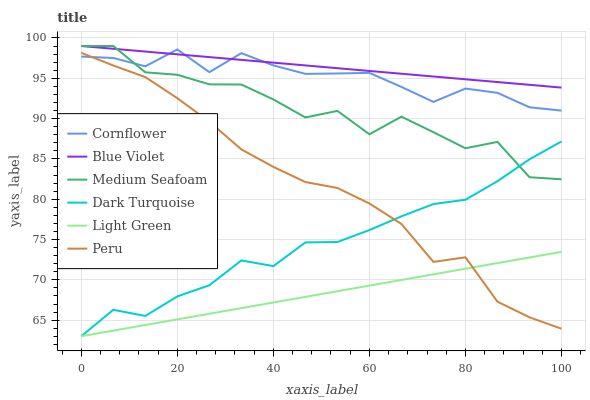Does Light Green have the minimum area under the curve?
Answer yes or no. Yes. Does Blue Violet have the maximum area under the curve?
Answer yes or no. Yes. Does Dark Turquoise have the minimum area under the curve?
Answer yes or no. No. Does Dark Turquoise have the maximum area under the curve?
Answer yes or no. No. Is Light Green the smoothest?
Answer yes or no. Yes. Is Medium Seafoam the roughest?
Answer yes or no. Yes. Is Dark Turquoise the smoothest?
Answer yes or no. No. Is Dark Turquoise the roughest?
Answer yes or no. No. Does Light Green have the lowest value?
Answer yes or no. Yes. Does Peru have the lowest value?
Answer yes or no. No. Does Blue Violet have the highest value?
Answer yes or no. Yes. Does Dark Turquoise have the highest value?
Answer yes or no. No. Is Light Green less than Cornflower?
Answer yes or no. Yes. Is Blue Violet greater than Light Green?
Answer yes or no. Yes. Does Cornflower intersect Blue Violet?
Answer yes or no. Yes. Is Cornflower less than Blue Violet?
Answer yes or no. No. Is Cornflower greater than Blue Violet?
Answer yes or no. No. Does Light Green intersect Cornflower?
Answer yes or no. No. 